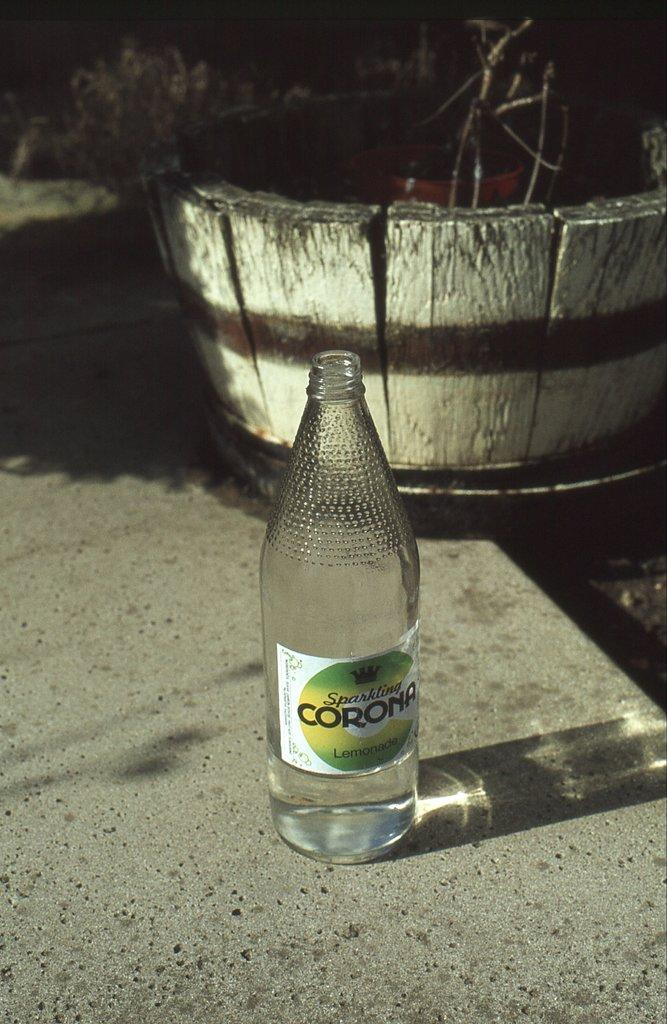<image>
Give a short and clear explanation of the subsequent image. An empty bottle of Corona sitting on the concrete next to a basket, 